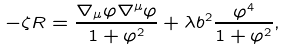Convert formula to latex. <formula><loc_0><loc_0><loc_500><loc_500>- \zeta { R } = \frac { \nabla _ { \mu } \varphi \nabla ^ { \mu } \varphi } { 1 + \varphi ^ { 2 } } + \lambda { b } ^ { 2 } \frac { \varphi ^ { 4 } } { 1 + \varphi ^ { 2 } } ,</formula> 